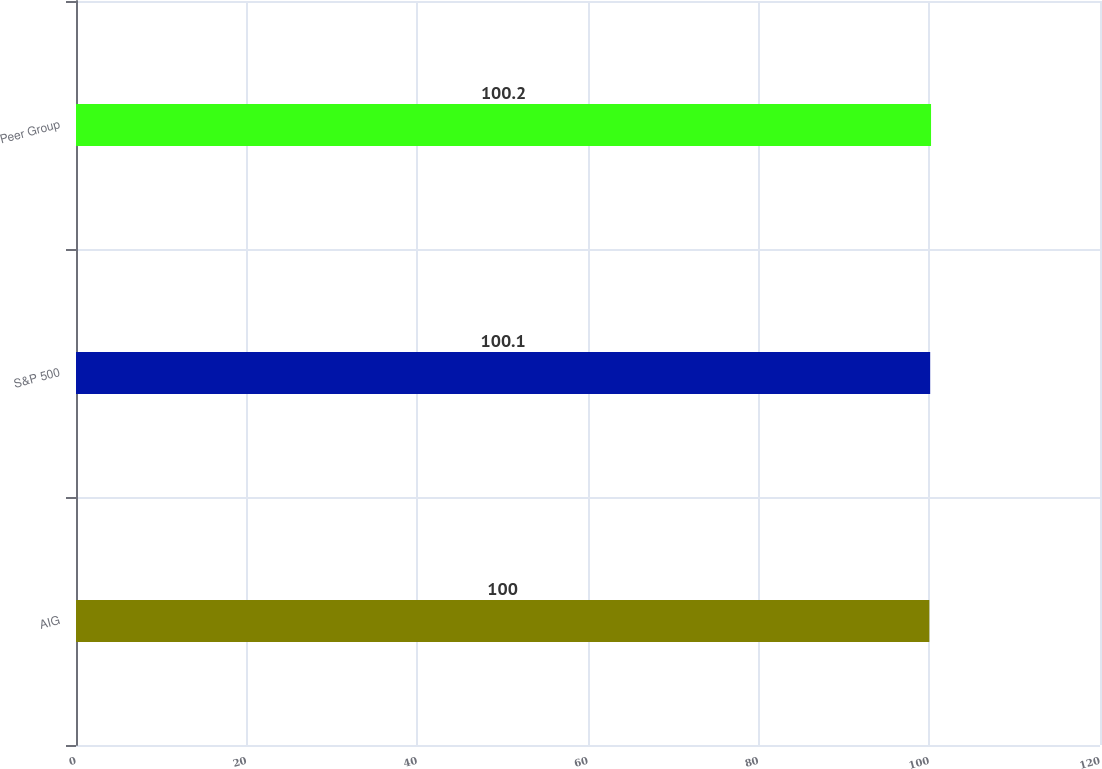Convert chart. <chart><loc_0><loc_0><loc_500><loc_500><bar_chart><fcel>AIG<fcel>S&P 500<fcel>Peer Group<nl><fcel>100<fcel>100.1<fcel>100.2<nl></chart> 